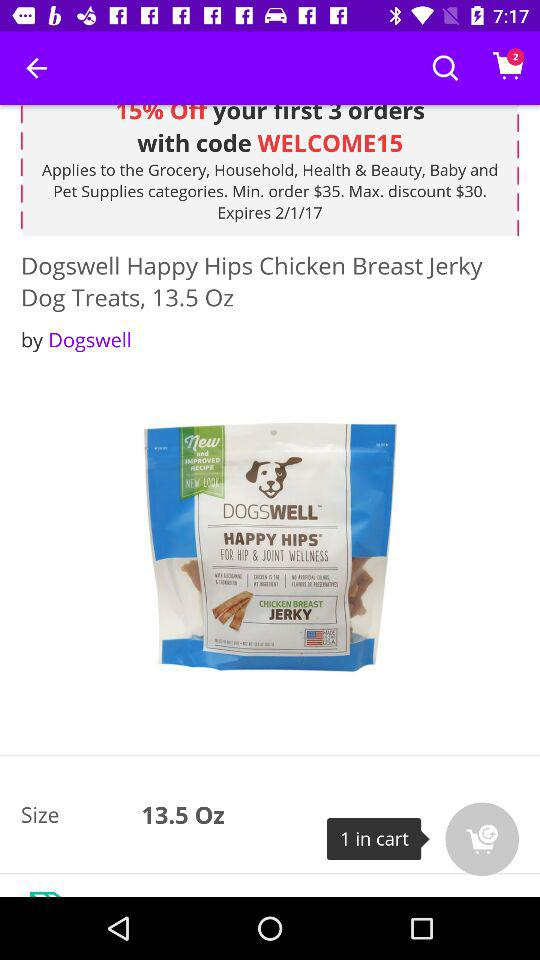What is the size? The weight is 13.5 oz. 